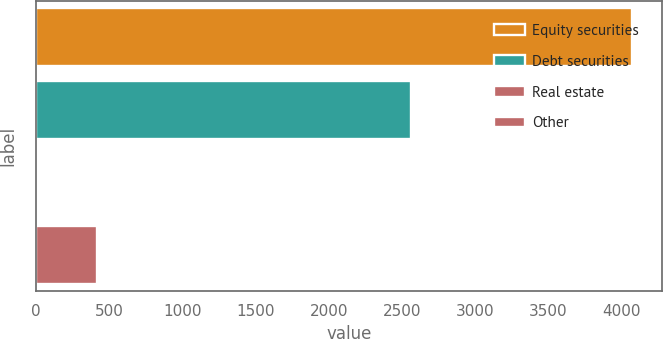<chart> <loc_0><loc_0><loc_500><loc_500><bar_chart><fcel>Equity securities<fcel>Debt securities<fcel>Real estate<fcel>Other<nl><fcel>4075<fcel>2560<fcel>10<fcel>416.5<nl></chart> 